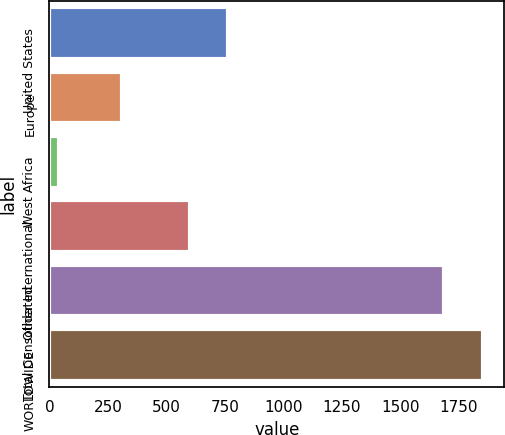Convert chart to OTSL. <chart><loc_0><loc_0><loc_500><loc_500><bar_chart><fcel>United States<fcel>Europe<fcel>West Africa<fcel>Other International<fcel>Total Consolidated<fcel>WORLDWIDE<nl><fcel>764.4<fcel>312<fcel>42<fcel>599<fcel>1686<fcel>1851.4<nl></chart> 